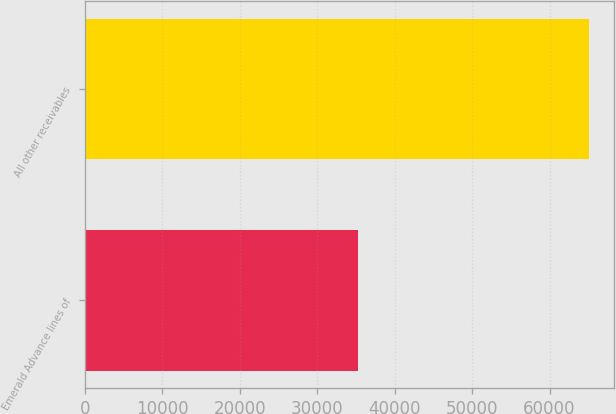<chart> <loc_0><loc_0><loc_500><loc_500><bar_chart><fcel>Emerald Advance lines of<fcel>All other receivables<nl><fcel>35239<fcel>65041<nl></chart> 